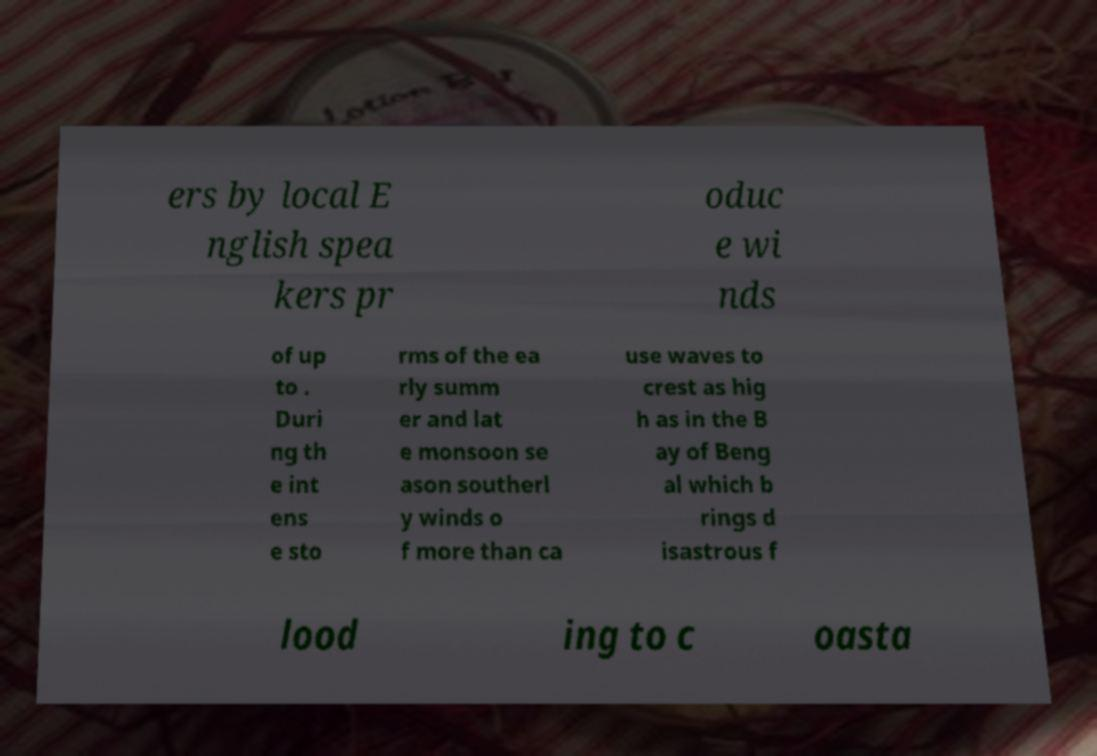Please read and relay the text visible in this image. What does it say? ers by local E nglish spea kers pr oduc e wi nds of up to . Duri ng th e int ens e sto rms of the ea rly summ er and lat e monsoon se ason southerl y winds o f more than ca use waves to crest as hig h as in the B ay of Beng al which b rings d isastrous f lood ing to c oasta 